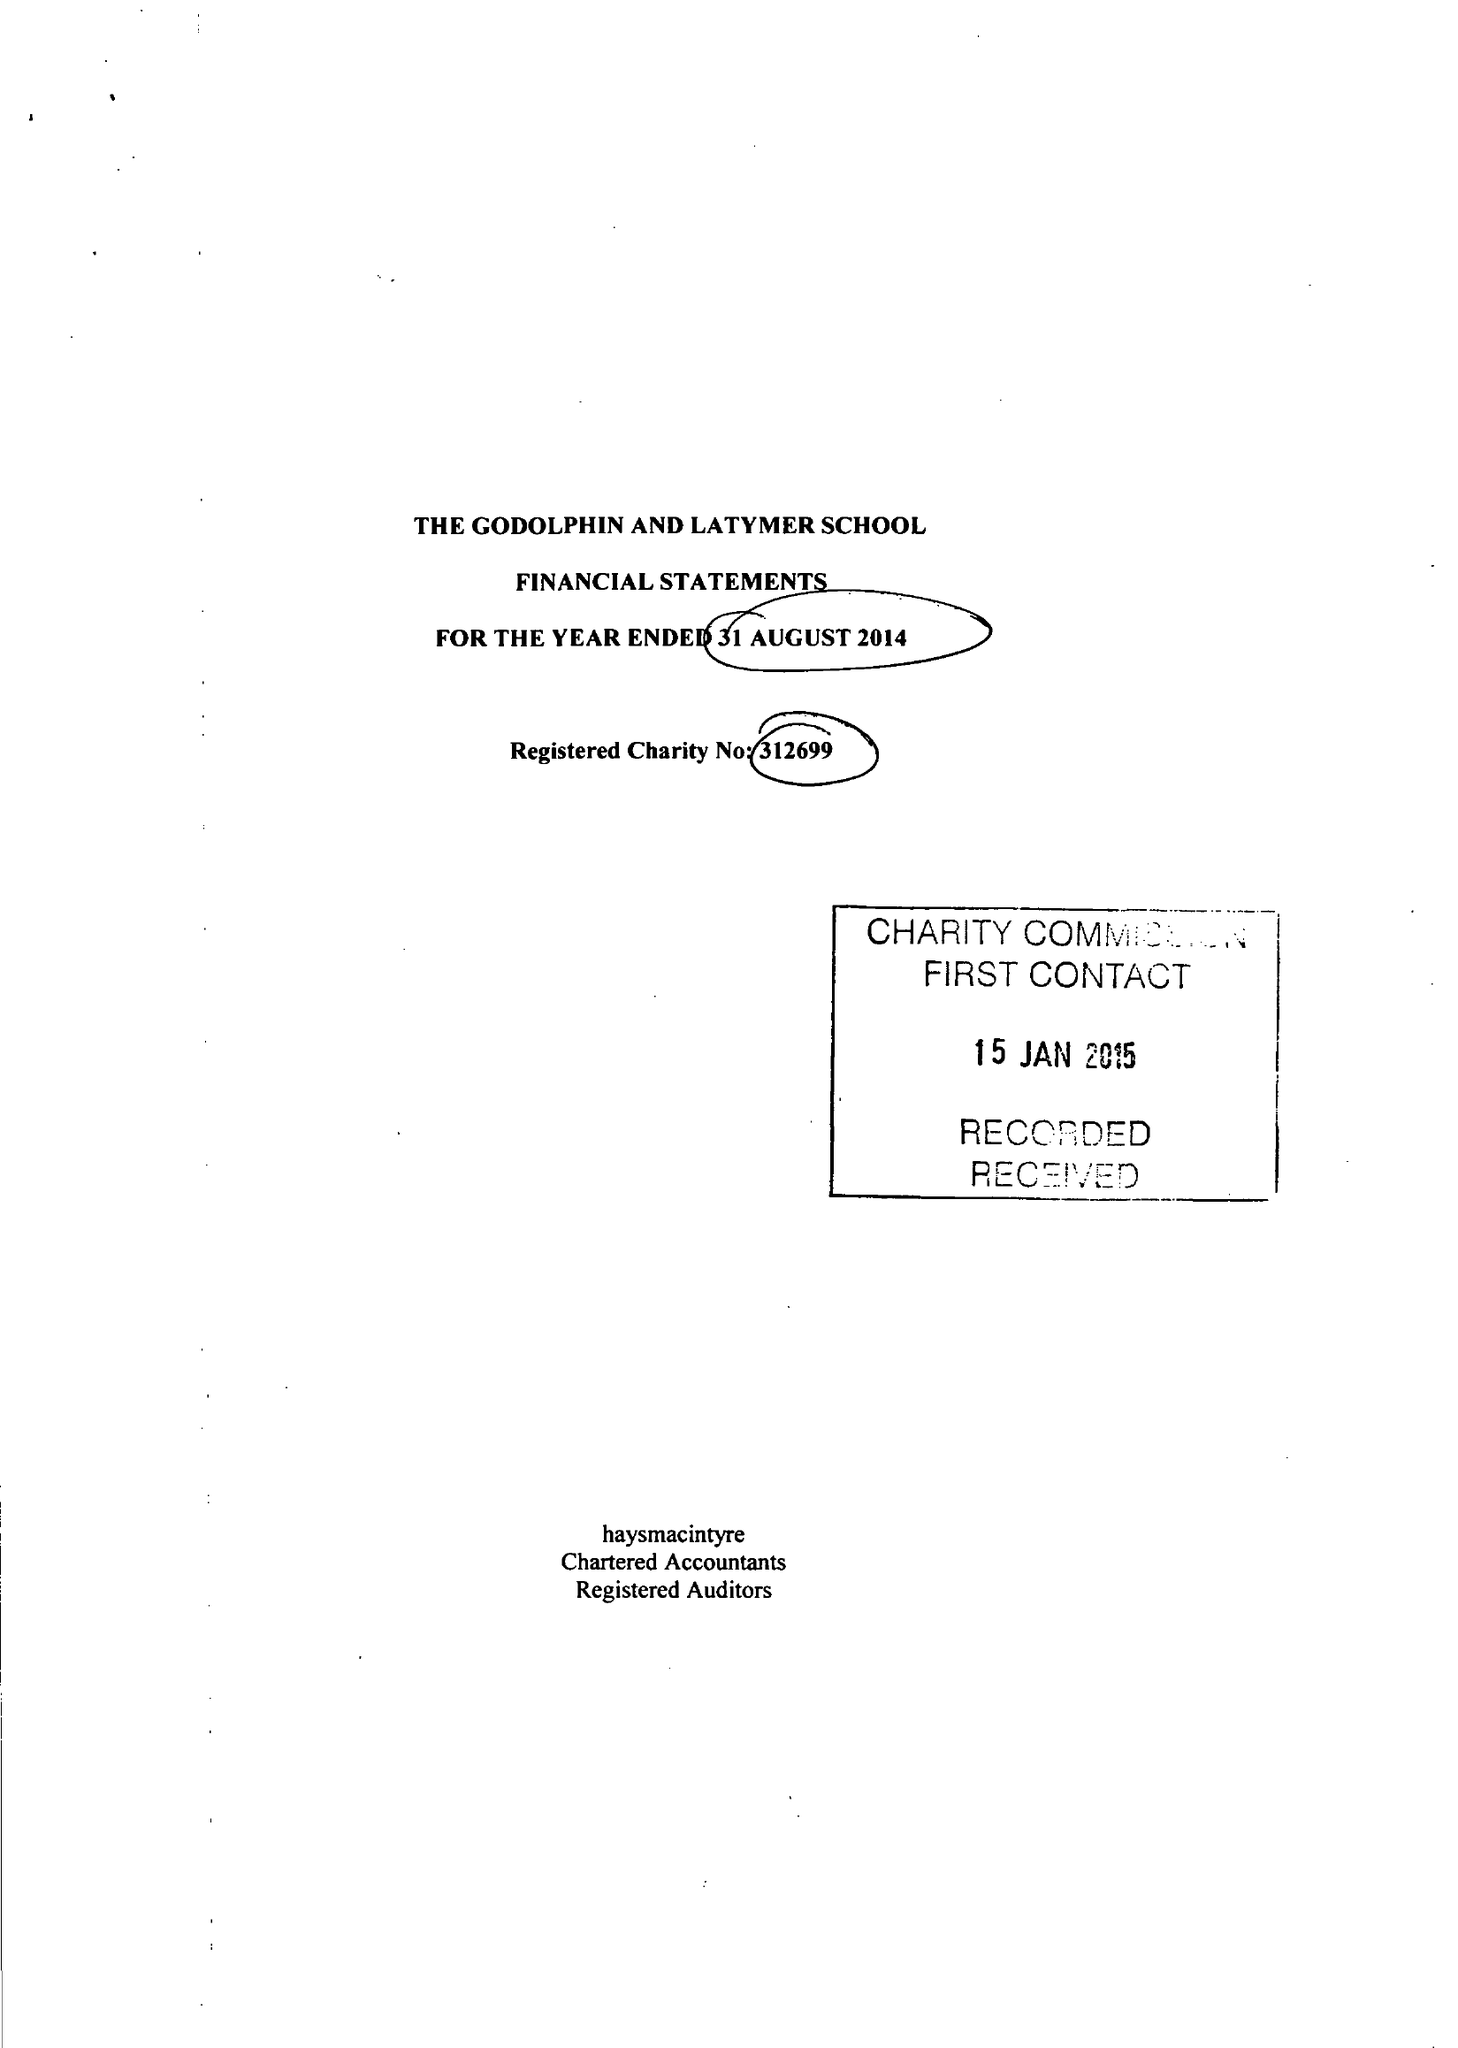What is the value for the income_annually_in_british_pounds?
Answer the question using a single word or phrase. 14309047.00 